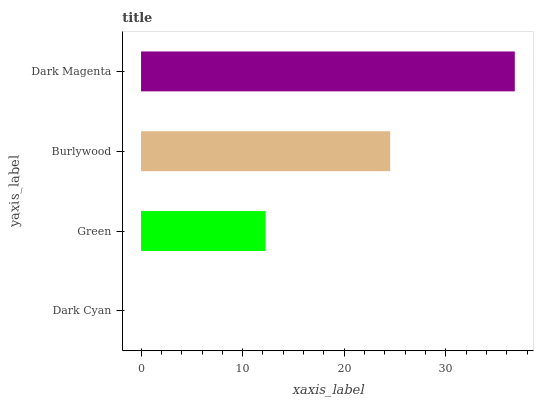Is Dark Cyan the minimum?
Answer yes or no. Yes. Is Dark Magenta the maximum?
Answer yes or no. Yes. Is Green the minimum?
Answer yes or no. No. Is Green the maximum?
Answer yes or no. No. Is Green greater than Dark Cyan?
Answer yes or no. Yes. Is Dark Cyan less than Green?
Answer yes or no. Yes. Is Dark Cyan greater than Green?
Answer yes or no. No. Is Green less than Dark Cyan?
Answer yes or no. No. Is Burlywood the high median?
Answer yes or no. Yes. Is Green the low median?
Answer yes or no. Yes. Is Green the high median?
Answer yes or no. No. Is Dark Magenta the low median?
Answer yes or no. No. 